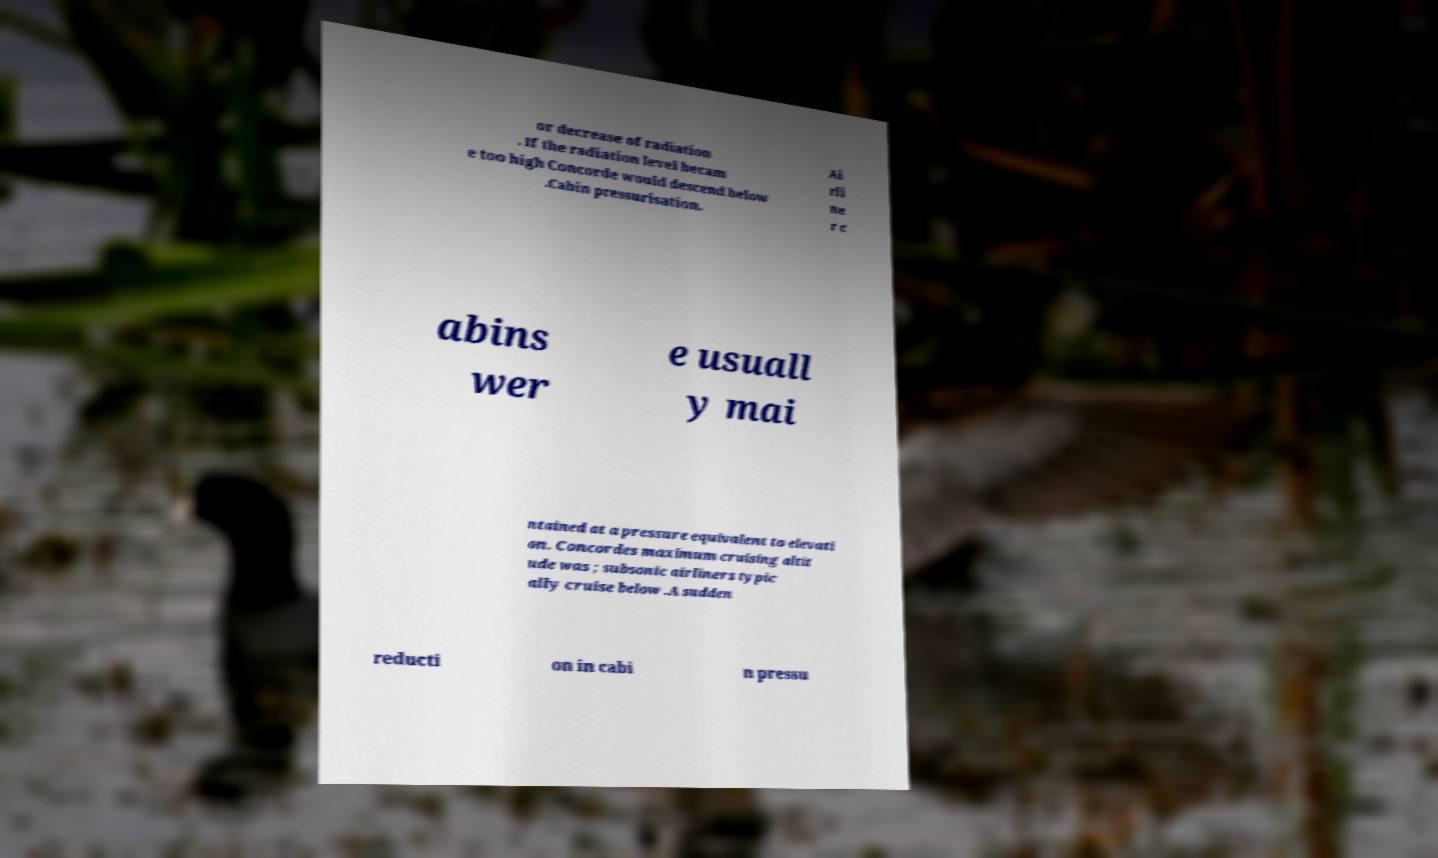For documentation purposes, I need the text within this image transcribed. Could you provide that? or decrease of radiation . If the radiation level becam e too high Concorde would descend below .Cabin pressurisation. Ai rli ne r c abins wer e usuall y mai ntained at a pressure equivalent to elevati on. Concordes maximum cruising altit ude was ; subsonic airliners typic ally cruise below .A sudden reducti on in cabi n pressu 